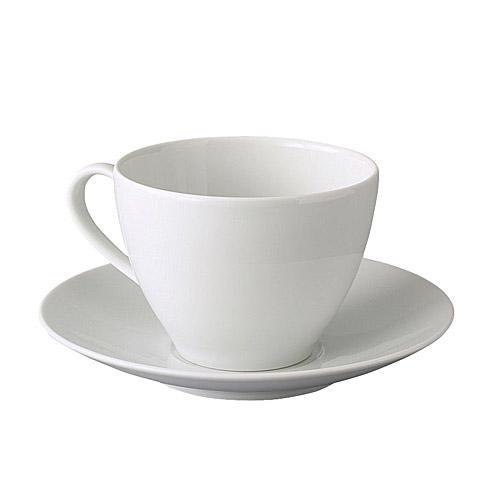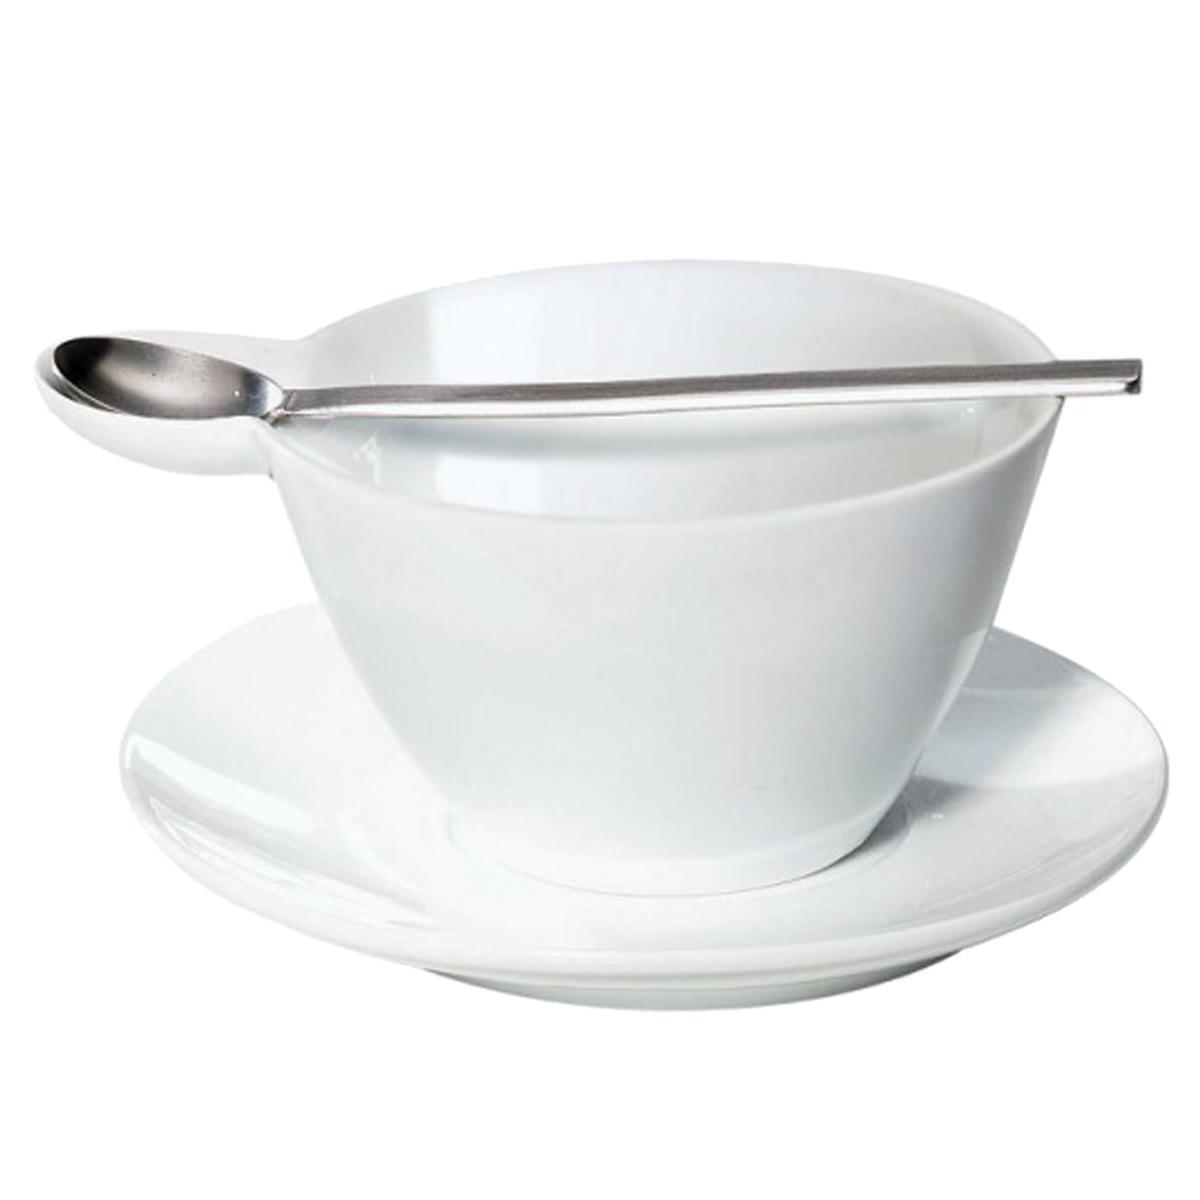The first image is the image on the left, the second image is the image on the right. Examine the images to the left and right. Is the description "Measuring spoons and cups appear in at least one image." accurate? Answer yes or no. No. 